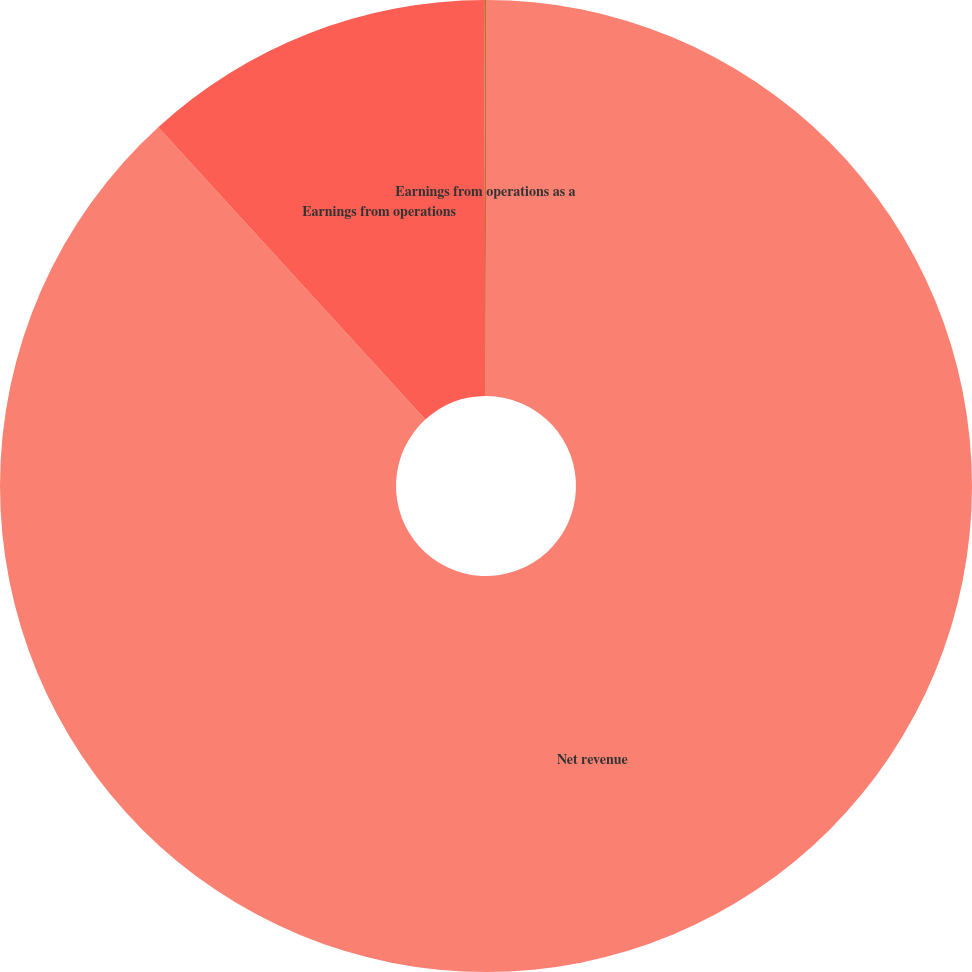Convert chart. <chart><loc_0><loc_0><loc_500><loc_500><pie_chart><fcel>Net revenue<fcel>Earnings from operations<fcel>Earnings from operations as a<nl><fcel>88.22%<fcel>11.72%<fcel>0.06%<nl></chart> 